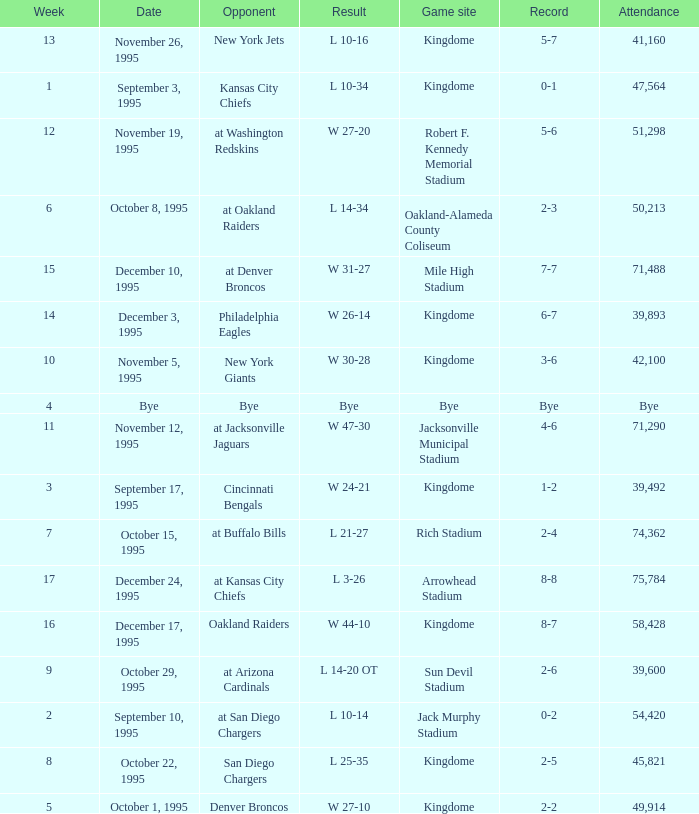Who was the opponent when the Seattle Seahawks had a record of 0-1? Kansas City Chiefs. 